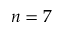Convert formula to latex. <formula><loc_0><loc_0><loc_500><loc_500>n = 7</formula> 